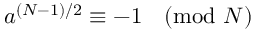<formula> <loc_0><loc_0><loc_500><loc_500>a ^ { ( N - 1 ) / 2 } \equiv - 1 { \pmod { N } }</formula> 